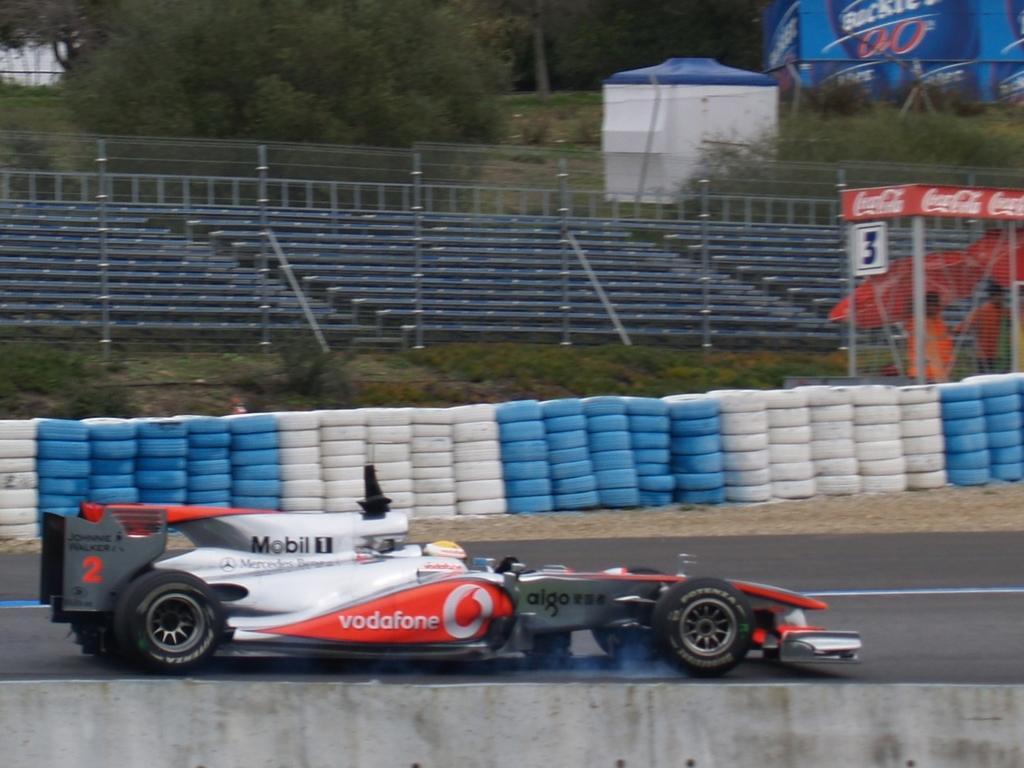How would you summarize this image in a sentence or two? In this picture we can see a wall from left to right. There is a car visible on the road. We can see a blue and white objects at the back. We can see a fence. Behind the fence, we can see two people and umbrellas. We can see a few rods, white object, trees and other things in the background. 